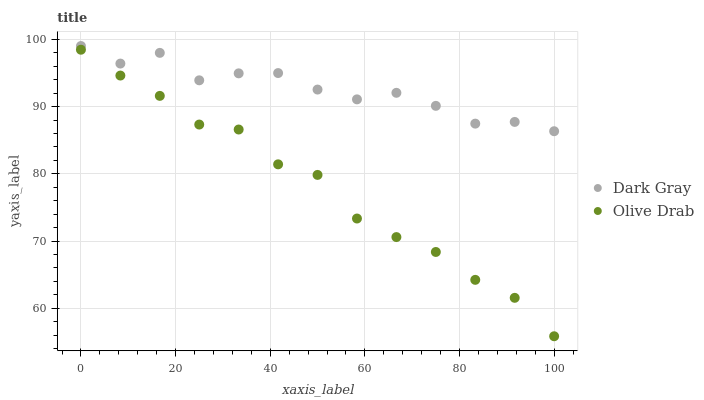Does Olive Drab have the minimum area under the curve?
Answer yes or no. Yes. Does Dark Gray have the maximum area under the curve?
Answer yes or no. Yes. Does Olive Drab have the maximum area under the curve?
Answer yes or no. No. Is Olive Drab the smoothest?
Answer yes or no. Yes. Is Dark Gray the roughest?
Answer yes or no. Yes. Is Olive Drab the roughest?
Answer yes or no. No. Does Olive Drab have the lowest value?
Answer yes or no. Yes. Does Dark Gray have the highest value?
Answer yes or no. Yes. Does Olive Drab have the highest value?
Answer yes or no. No. Is Olive Drab less than Dark Gray?
Answer yes or no. Yes. Is Dark Gray greater than Olive Drab?
Answer yes or no. Yes. Does Olive Drab intersect Dark Gray?
Answer yes or no. No. 